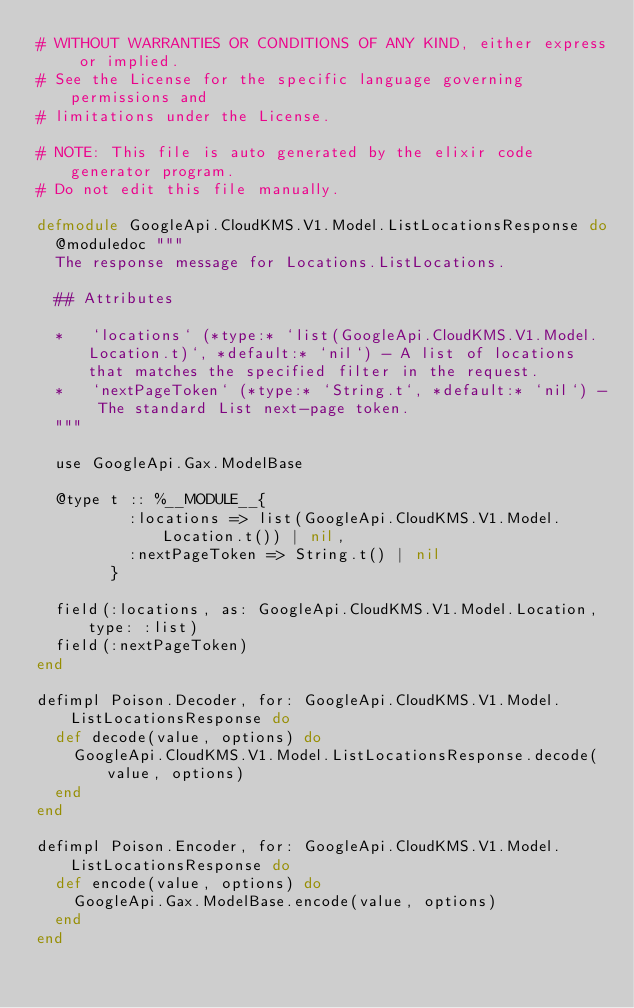Convert code to text. <code><loc_0><loc_0><loc_500><loc_500><_Elixir_># WITHOUT WARRANTIES OR CONDITIONS OF ANY KIND, either express or implied.
# See the License for the specific language governing permissions and
# limitations under the License.

# NOTE: This file is auto generated by the elixir code generator program.
# Do not edit this file manually.

defmodule GoogleApi.CloudKMS.V1.Model.ListLocationsResponse do
  @moduledoc """
  The response message for Locations.ListLocations.

  ## Attributes

  *   `locations` (*type:* `list(GoogleApi.CloudKMS.V1.Model.Location.t)`, *default:* `nil`) - A list of locations that matches the specified filter in the request.
  *   `nextPageToken` (*type:* `String.t`, *default:* `nil`) - The standard List next-page token.
  """

  use GoogleApi.Gax.ModelBase

  @type t :: %__MODULE__{
          :locations => list(GoogleApi.CloudKMS.V1.Model.Location.t()) | nil,
          :nextPageToken => String.t() | nil
        }

  field(:locations, as: GoogleApi.CloudKMS.V1.Model.Location, type: :list)
  field(:nextPageToken)
end

defimpl Poison.Decoder, for: GoogleApi.CloudKMS.V1.Model.ListLocationsResponse do
  def decode(value, options) do
    GoogleApi.CloudKMS.V1.Model.ListLocationsResponse.decode(value, options)
  end
end

defimpl Poison.Encoder, for: GoogleApi.CloudKMS.V1.Model.ListLocationsResponse do
  def encode(value, options) do
    GoogleApi.Gax.ModelBase.encode(value, options)
  end
end
</code> 